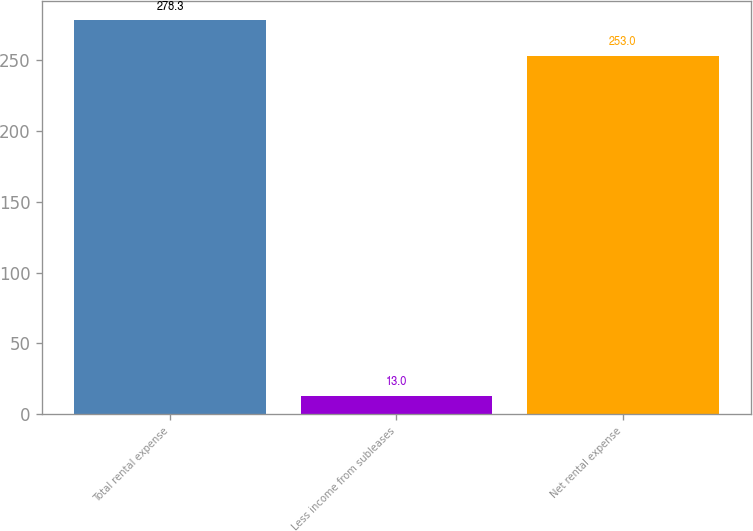Convert chart to OTSL. <chart><loc_0><loc_0><loc_500><loc_500><bar_chart><fcel>Total rental expense<fcel>Less income from subleases<fcel>Net rental expense<nl><fcel>278.3<fcel>13<fcel>253<nl></chart> 